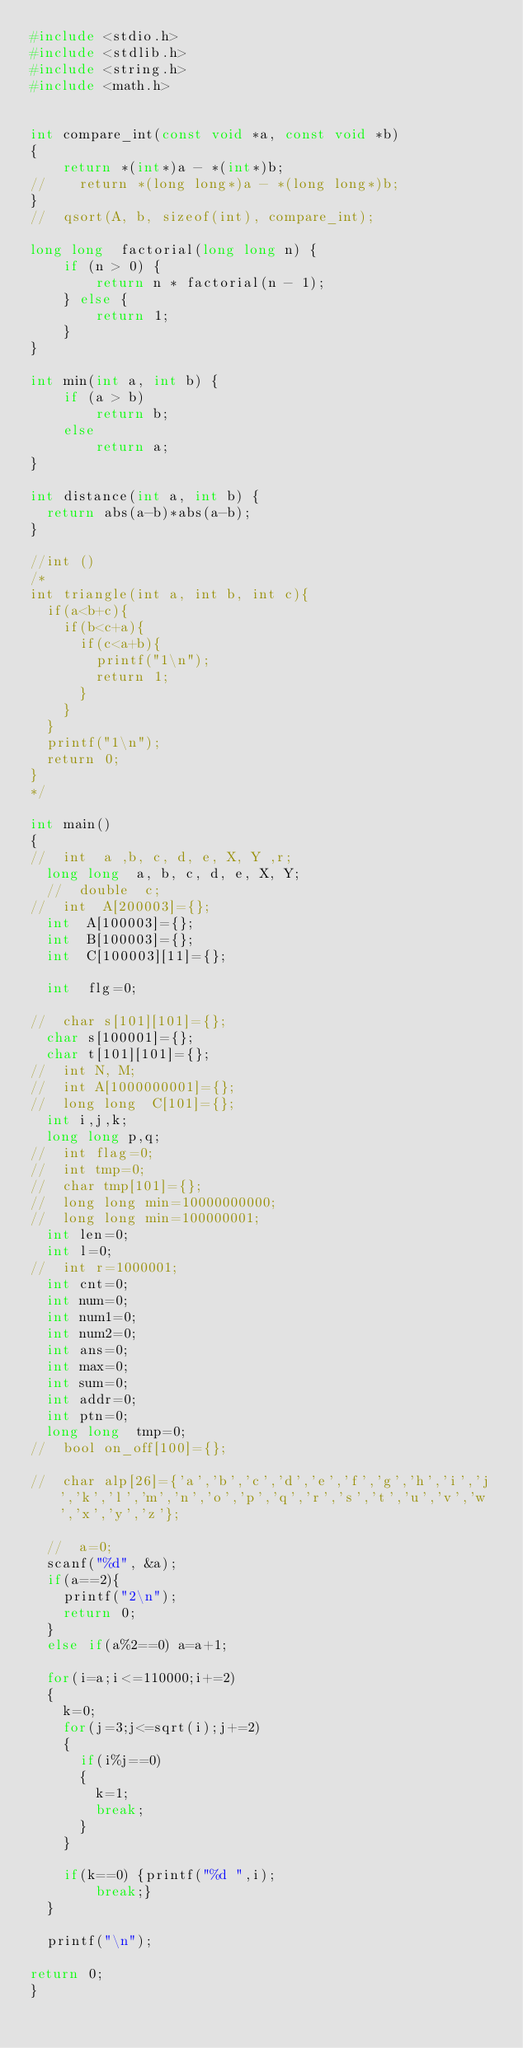Convert code to text. <code><loc_0><loc_0><loc_500><loc_500><_C_>#include <stdio.h>
#include <stdlib.h>
#include <string.h>
#include <math.h>


int compare_int(const void *a, const void *b)
{
    return *(int*)a - *(int*)b;
//    return *(long long*)a - *(long long*)b;
}
//  qsort(A, b, sizeof(int), compare_int);

long long  factorial(long long n) {
    if (n > 0) {
        return n * factorial(n - 1);
    } else {
        return 1;
    }
}

int min(int a, int b) {
    if (a > b)
        return b;
    else
        return a;
}

int distance(int a, int b) {
  return abs(a-b)*abs(a-b);
}

//int ()
/*
int triangle(int a, int b, int c){
  if(a<b+c){
    if(b<c+a){
      if(c<a+b){
        printf("1\n");
        return 1;
      }
    }
  }
  printf("1\n");
  return 0;
}
*/

int main()
{
//  int  a ,b, c, d, e, X, Y ,r;
  long long  a, b, c, d, e, X, Y;
  //  double  c;
//  int  A[200003]={};
  int  A[100003]={};
  int  B[100003]={};
  int  C[100003][11]={};

  int  flg=0;

//  char s[101][101]={};
  char s[100001]={};
  char t[101][101]={};
//  int N, M;
//  int A[1000000001]={};
//  long long  C[101]={};
  int i,j,k;
  long long p,q;
//  int flag=0;
//  int tmp=0;
//  char tmp[101]={};
//  long long min=10000000000;
//  long long min=100000001;
  int len=0;
  int l=0;
//  int r=1000001;
  int cnt=0;
  int num=0;
  int num1=0;
  int num2=0;
  int ans=0;
  int max=0;
  int sum=0;
  int addr=0;
  int ptn=0;
  long long  tmp=0;
//  bool on_off[100]={};
  
//  char alp[26]={'a','b','c','d','e','f','g','h','i','j','k','l','m','n','o','p','q','r','s','t','u','v','w','x','y','z'};

  //  a=0;
  scanf("%d", &a);
  if(a==2){
    printf("2\n");
    return 0;
  }
  else if(a%2==0) a=a+1;
  
  for(i=a;i<=110000;i+=2)
	{
		k=0;
		for(j=3;j<=sqrt(i);j+=2)
		{
			if(i%j==0)
			{
				k=1;
				break;
			}
		}

		if(k==0) {printf("%d ",i);
        break;}
	}

	printf("\n");
  
return 0;
}
</code> 